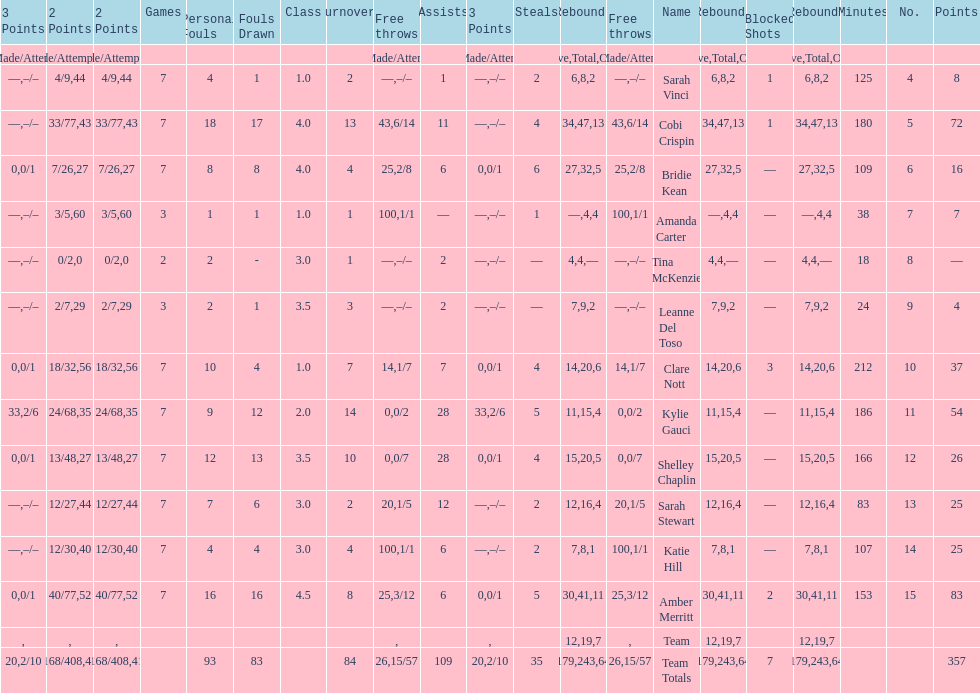After playing seven games, how many players individual points were above 30? 4. 